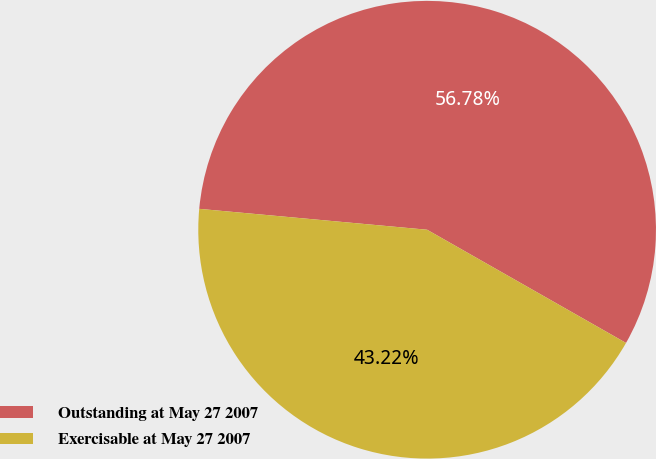Convert chart. <chart><loc_0><loc_0><loc_500><loc_500><pie_chart><fcel>Outstanding at May 27 2007<fcel>Exercisable at May 27 2007<nl><fcel>56.78%<fcel>43.22%<nl></chart> 